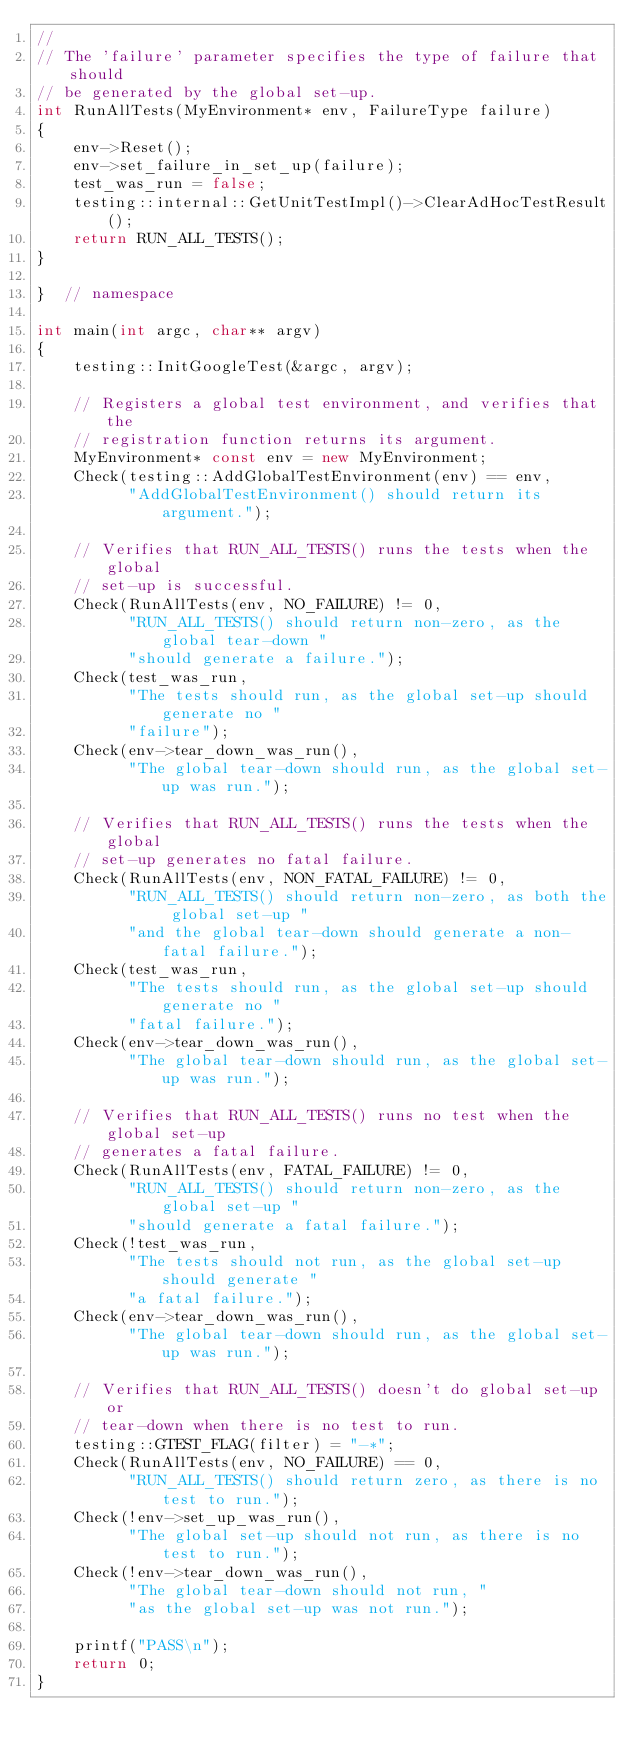Convert code to text. <code><loc_0><loc_0><loc_500><loc_500><_C++_>//
// The 'failure' parameter specifies the type of failure that should
// be generated by the global set-up.
int RunAllTests(MyEnvironment* env, FailureType failure)
{
    env->Reset();
    env->set_failure_in_set_up(failure);
    test_was_run = false;
    testing::internal::GetUnitTestImpl()->ClearAdHocTestResult();
    return RUN_ALL_TESTS();
}

}  // namespace

int main(int argc, char** argv)
{
    testing::InitGoogleTest(&argc, argv);

    // Registers a global test environment, and verifies that the
    // registration function returns its argument.
    MyEnvironment* const env = new MyEnvironment;
    Check(testing::AddGlobalTestEnvironment(env) == env,
          "AddGlobalTestEnvironment() should return its argument.");

    // Verifies that RUN_ALL_TESTS() runs the tests when the global
    // set-up is successful.
    Check(RunAllTests(env, NO_FAILURE) != 0,
          "RUN_ALL_TESTS() should return non-zero, as the global tear-down "
          "should generate a failure.");
    Check(test_was_run,
          "The tests should run, as the global set-up should generate no "
          "failure");
    Check(env->tear_down_was_run(),
          "The global tear-down should run, as the global set-up was run.");

    // Verifies that RUN_ALL_TESTS() runs the tests when the global
    // set-up generates no fatal failure.
    Check(RunAllTests(env, NON_FATAL_FAILURE) != 0,
          "RUN_ALL_TESTS() should return non-zero, as both the global set-up "
          "and the global tear-down should generate a non-fatal failure.");
    Check(test_was_run,
          "The tests should run, as the global set-up should generate no "
          "fatal failure.");
    Check(env->tear_down_was_run(),
          "The global tear-down should run, as the global set-up was run.");

    // Verifies that RUN_ALL_TESTS() runs no test when the global set-up
    // generates a fatal failure.
    Check(RunAllTests(env, FATAL_FAILURE) != 0,
          "RUN_ALL_TESTS() should return non-zero, as the global set-up "
          "should generate a fatal failure.");
    Check(!test_was_run,
          "The tests should not run, as the global set-up should generate "
          "a fatal failure.");
    Check(env->tear_down_was_run(),
          "The global tear-down should run, as the global set-up was run.");

    // Verifies that RUN_ALL_TESTS() doesn't do global set-up or
    // tear-down when there is no test to run.
    testing::GTEST_FLAG(filter) = "-*";
    Check(RunAllTests(env, NO_FAILURE) == 0,
          "RUN_ALL_TESTS() should return zero, as there is no test to run.");
    Check(!env->set_up_was_run(),
          "The global set-up should not run, as there is no test to run.");
    Check(!env->tear_down_was_run(),
          "The global tear-down should not run, "
          "as the global set-up was not run.");

    printf("PASS\n");
    return 0;
}
</code> 